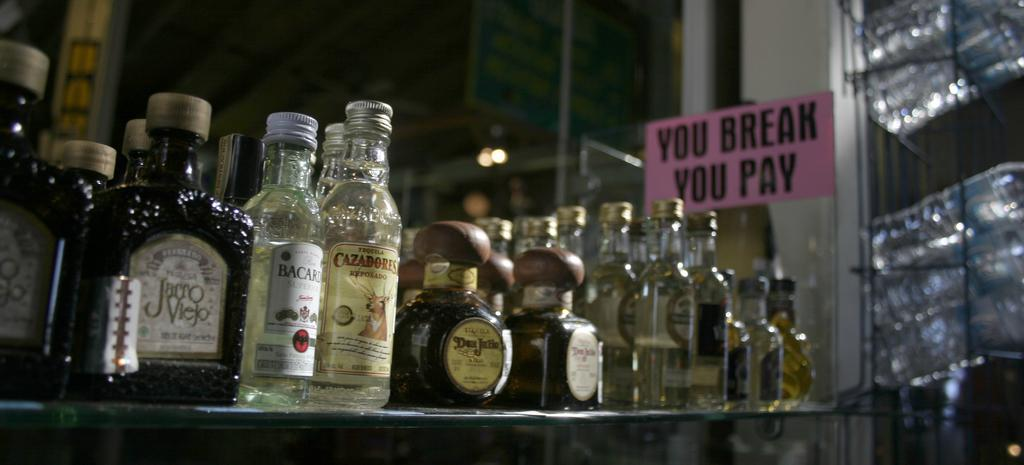<image>
Share a concise interpretation of the image provided. A bunch of liquor bottles are aligned on a shelf next to a sign saying you break you pay. 